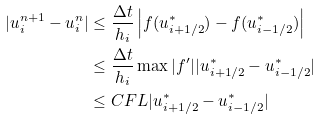Convert formula to latex. <formula><loc_0><loc_0><loc_500><loc_500>| u _ { i } ^ { n + 1 } - u _ { i } ^ { n } | & \leq \frac { \Delta t } { h _ { i } } \left | f ( u _ { i + 1 / 2 } ^ { \ast } ) - f ( u _ { i - 1 / 2 } ^ { \ast } ) \right | \\ & \leq \frac { \Delta t } { h _ { i } } \max | f ^ { \prime } | | u _ { i + 1 / 2 } ^ { \ast } - u _ { i - 1 / 2 } ^ { \ast } | \\ & \leq C F L | u _ { i + 1 / 2 } ^ { \ast } - u _ { i - 1 / 2 } ^ { \ast } |</formula> 